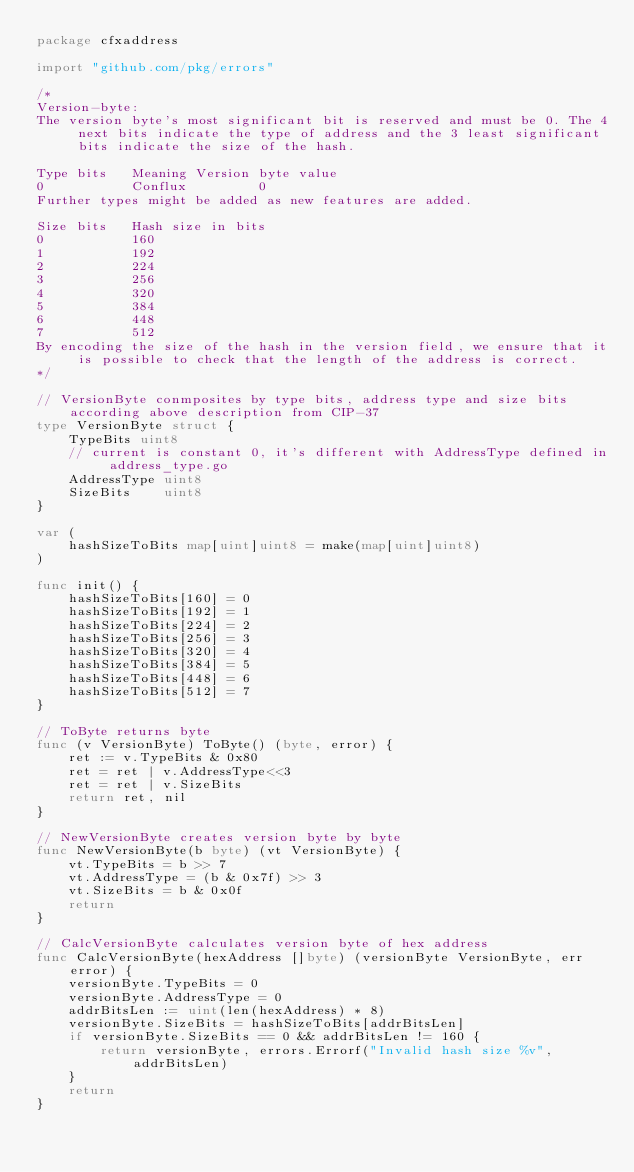<code> <loc_0><loc_0><loc_500><loc_500><_Go_>package cfxaddress

import "github.com/pkg/errors"

/*
Version-byte:
The version byte's most significant bit is reserved and must be 0. The 4 next bits indicate the type of address and the 3 least significant bits indicate the size of the hash.

Type bits	Meaning	Version byte value
0			Conflux			0
Further types might be added as new features are added.

Size bits	Hash size in bits
0			160
1			192
2			224
3			256
4			320
5			384
6			448
7			512
By encoding the size of the hash in the version field, we ensure that it is possible to check that the length of the address is correct.
*/

// VersionByte conmposites by type bits, address type and size bits according above description from CIP-37
type VersionByte struct {
	TypeBits uint8
	// current is constant 0, it's different with AddressType defined in address_type.go
	AddressType uint8
	SizeBits    uint8
}

var (
	hashSizeToBits map[uint]uint8 = make(map[uint]uint8)
)

func init() {
	hashSizeToBits[160] = 0
	hashSizeToBits[192] = 1
	hashSizeToBits[224] = 2
	hashSizeToBits[256] = 3
	hashSizeToBits[320] = 4
	hashSizeToBits[384] = 5
	hashSizeToBits[448] = 6
	hashSizeToBits[512] = 7
}

// ToByte returns byte
func (v VersionByte) ToByte() (byte, error) {
	ret := v.TypeBits & 0x80
	ret = ret | v.AddressType<<3
	ret = ret | v.SizeBits
	return ret, nil
}

// NewVersionByte creates version byte by byte
func NewVersionByte(b byte) (vt VersionByte) {
	vt.TypeBits = b >> 7
	vt.AddressType = (b & 0x7f) >> 3
	vt.SizeBits = b & 0x0f
	return
}

// CalcVersionByte calculates version byte of hex address
func CalcVersionByte(hexAddress []byte) (versionByte VersionByte, err error) {
	versionByte.TypeBits = 0
	versionByte.AddressType = 0
	addrBitsLen := uint(len(hexAddress) * 8)
	versionByte.SizeBits = hashSizeToBits[addrBitsLen]
	if versionByte.SizeBits == 0 && addrBitsLen != 160 {
		return versionByte, errors.Errorf("Invalid hash size %v", addrBitsLen)
	}
	return
}
</code> 